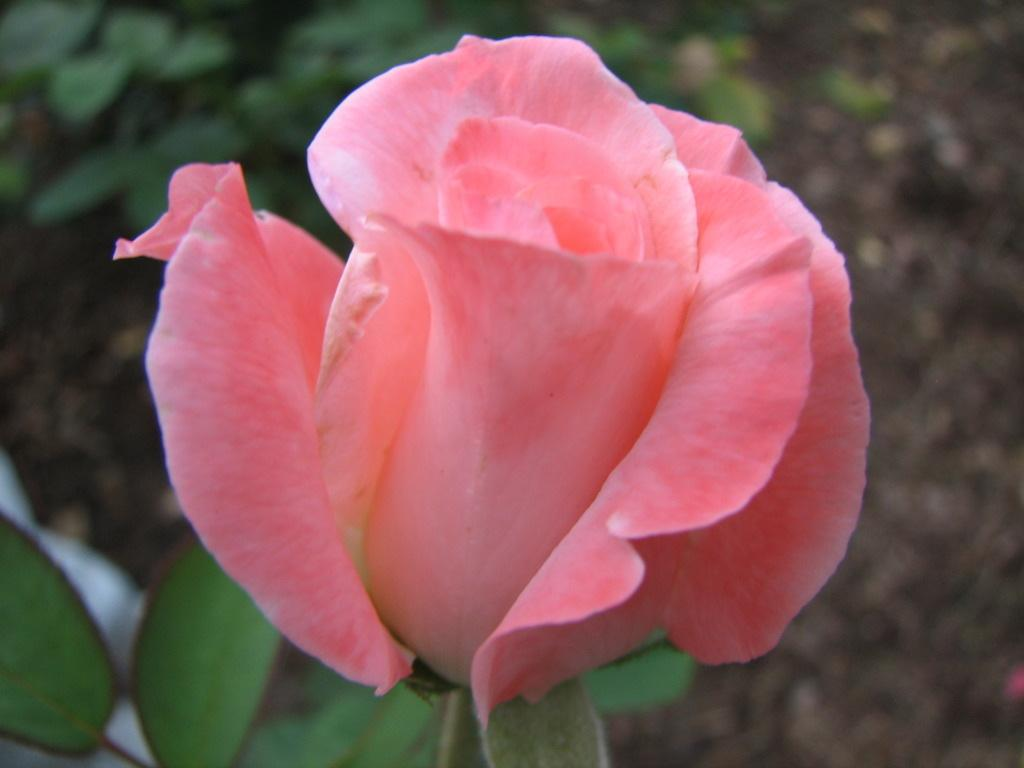What type of flower is in the image? There is a pink rose flower in the image. What color are the leaves of the flower? The rose flower has green leaves. How many pies are being baked by the rose flower in the image? There are no pies or baking activity present in the image; it features a pink rose flower with green leaves. 